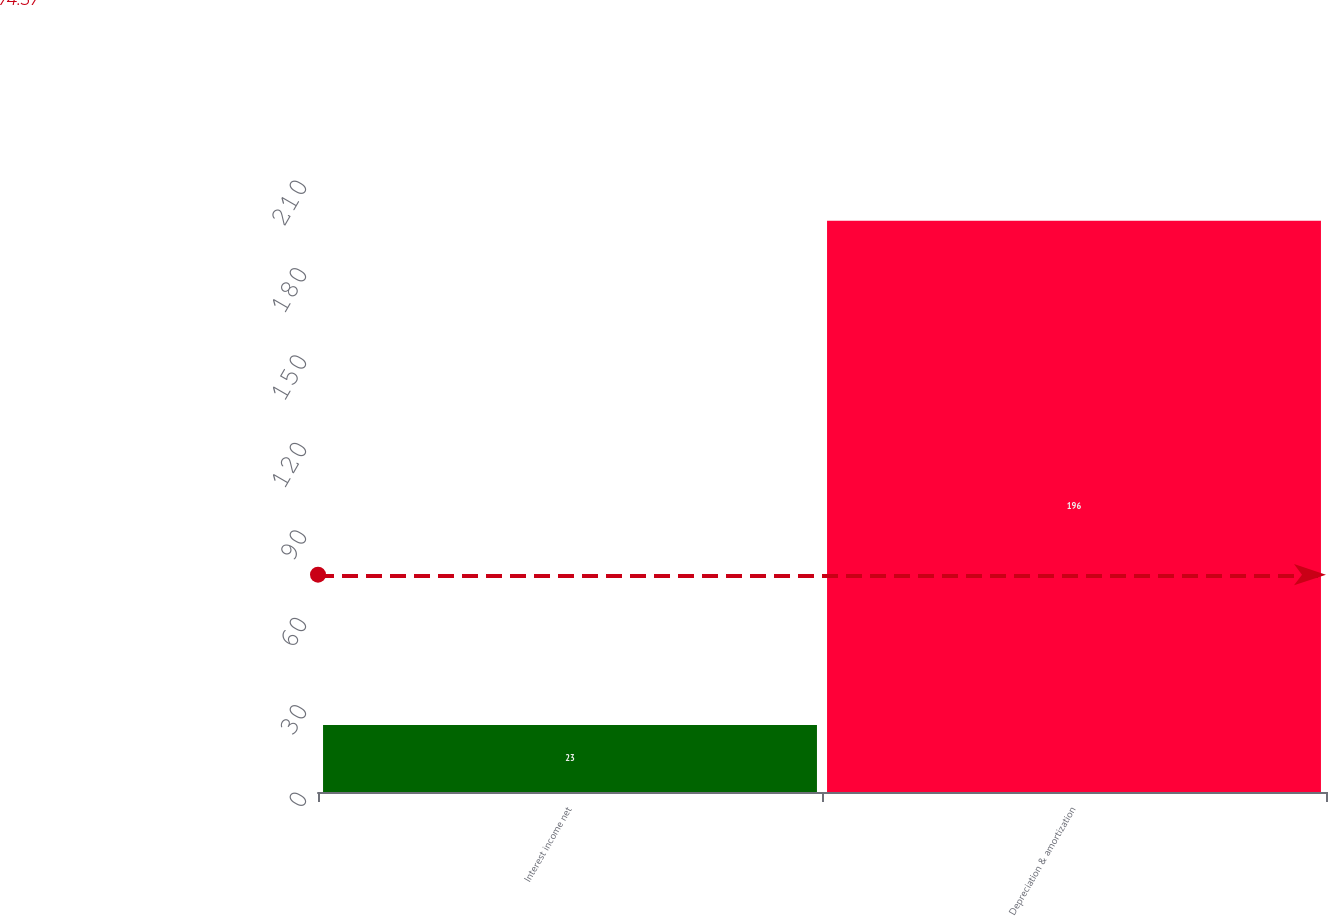Convert chart to OTSL. <chart><loc_0><loc_0><loc_500><loc_500><bar_chart><fcel>Interest income net<fcel>Depreciation & amortization<nl><fcel>23<fcel>196<nl></chart> 